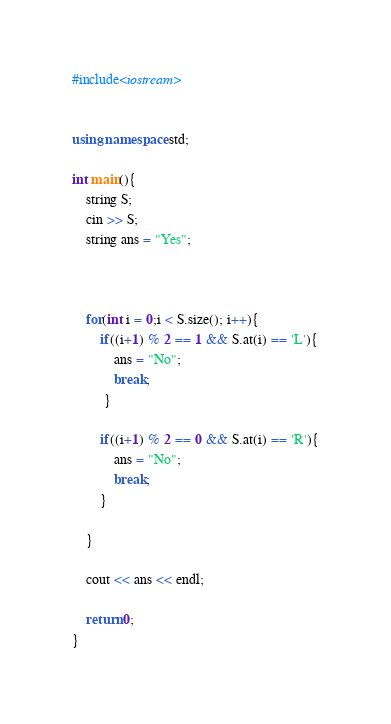Convert code to text. <code><loc_0><loc_0><loc_500><loc_500><_C++_>#include<iostream>


using namespace std;

int main(){
    string S;
    cin >> S;
    string ans = "Yes";
   

    
    for(int i = 0;i < S.size(); i++){  
        if((i+1) % 2 == 1 && S.at(i) == 'L'){
            ans = "No";
            break;
         }

        if((i+1) % 2 == 0 && S.at(i) == 'R'){
            ans = "No";
            break;
        }

    }

    cout << ans << endl;

    return 0;
}</code> 